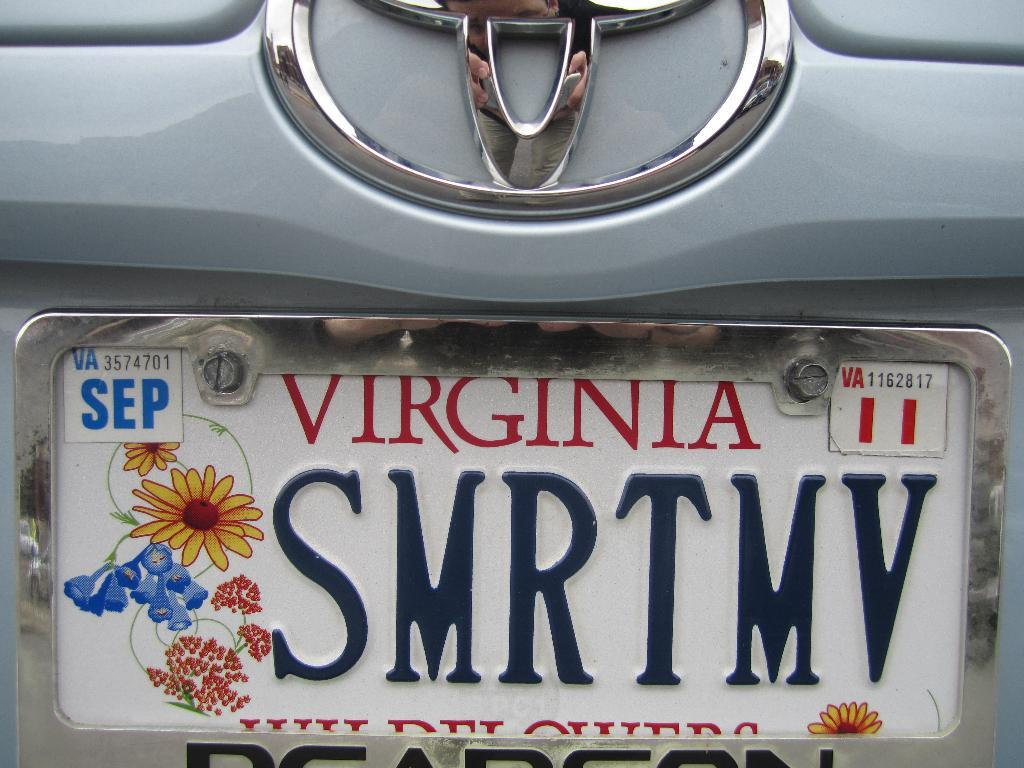<image>
Describe the image concisely. A Virginia licence plate with flowers and an expiration of September 